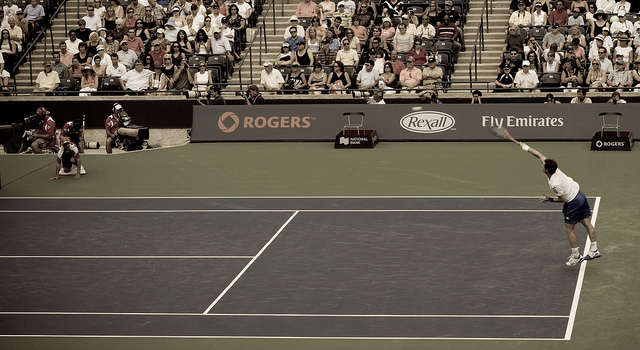Identify and read out the text in this image. ROGERS Rexall Fly Emirates ROGERS 